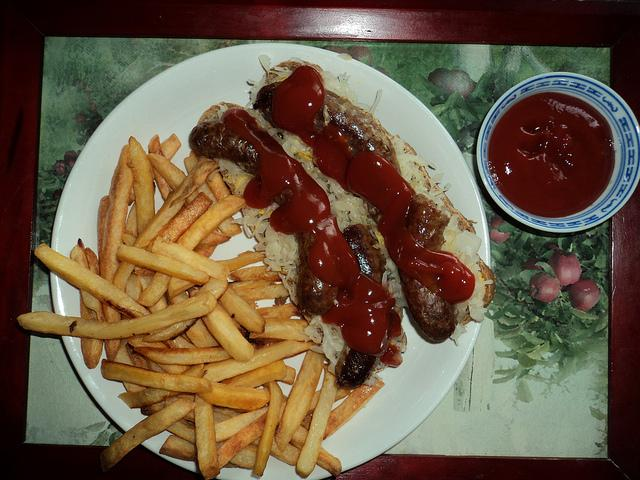What is the red sauce that is covering the hot dog sausages?

Choices:
A) oyster
B) ketchup
C) hoisen
D) hot sauce ketchup 